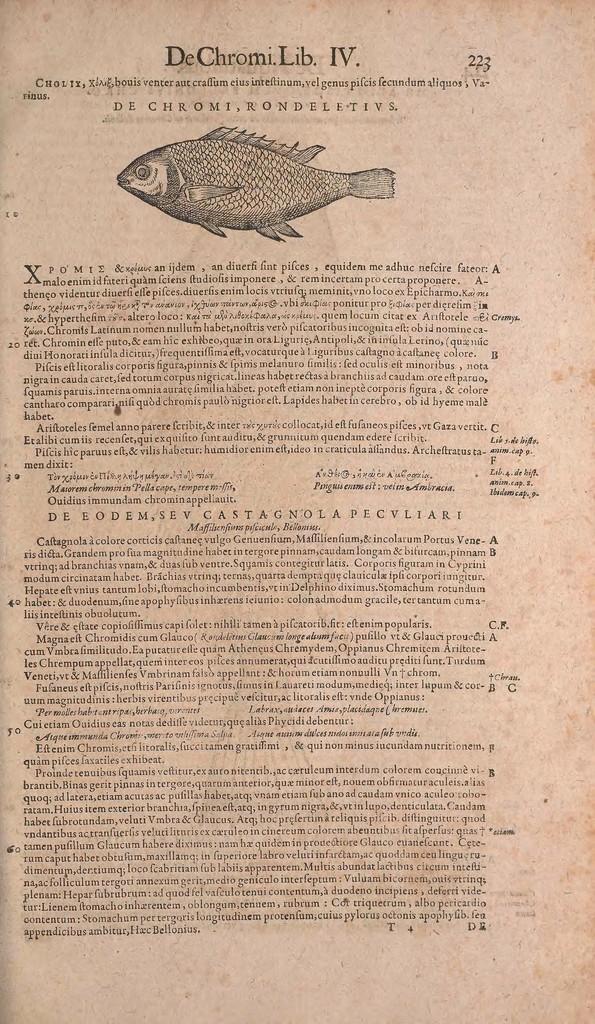Please provide a concise description of this image. In this image, we can see an article. At the top of the image, we can see a fish sketch. 